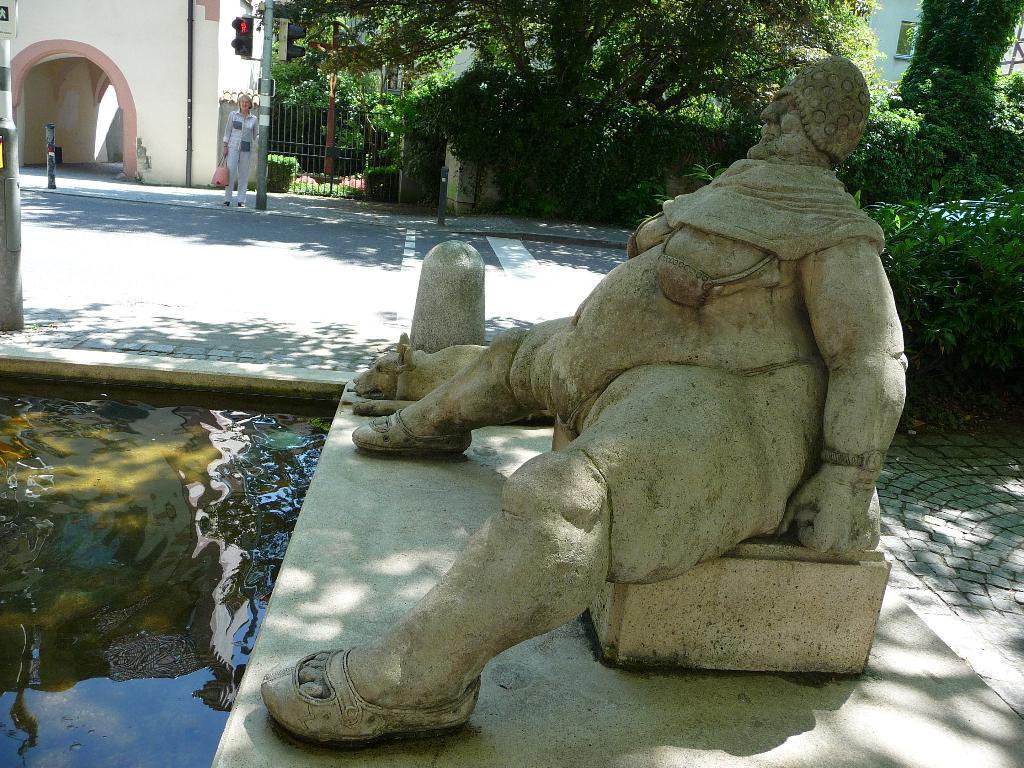Describe this image in one or two sentences. This statue is highlighted in this picture. Beside this statue there is a sculpture of a dog. In-front of this statue there are the water. The woman is standing beside the signal pole. she is holding a bag. Beside this pole there is gate in black color. Far there are trees in green color. Backside of this statue there are plants. It is a sunny day. The wall is in cream color. 